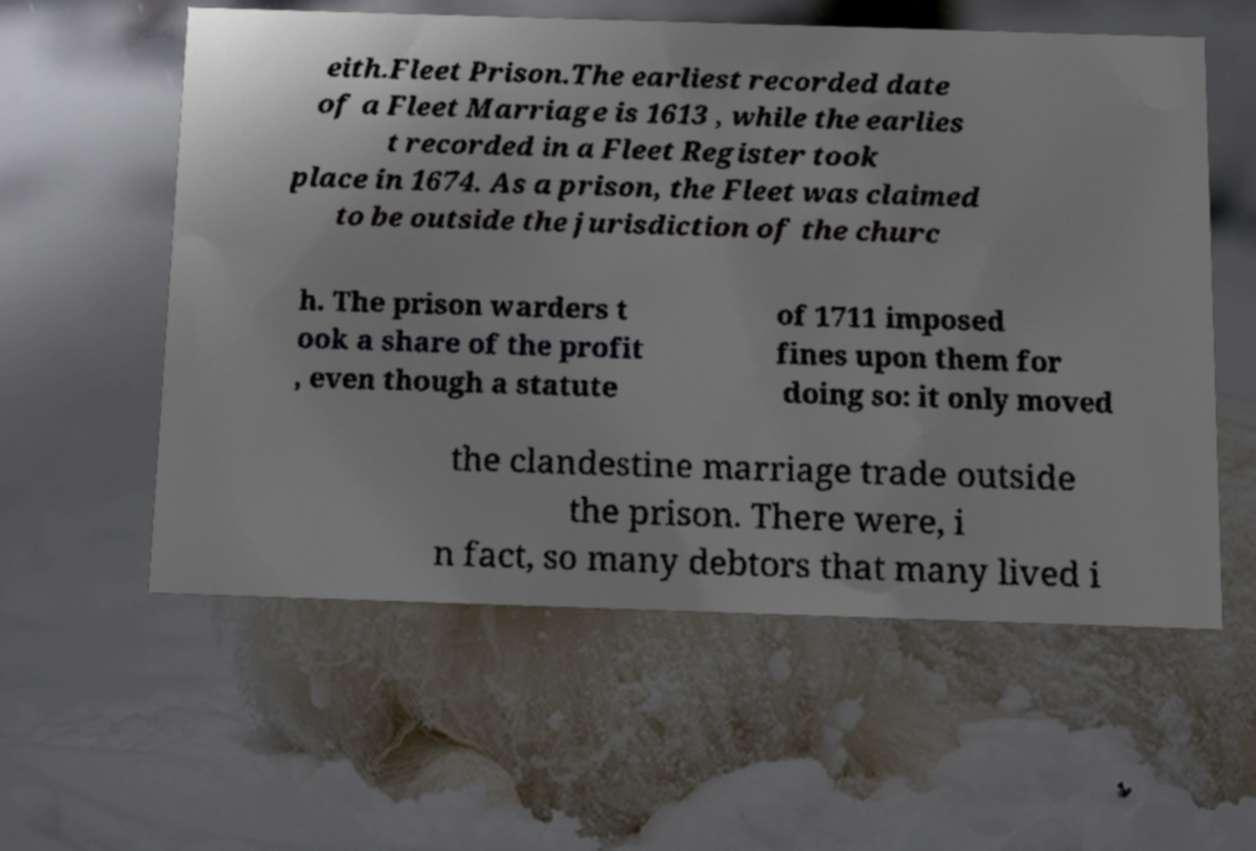Please read and relay the text visible in this image. What does it say? eith.Fleet Prison.The earliest recorded date of a Fleet Marriage is 1613 , while the earlies t recorded in a Fleet Register took place in 1674. As a prison, the Fleet was claimed to be outside the jurisdiction of the churc h. The prison warders t ook a share of the profit , even though a statute of 1711 imposed fines upon them for doing so: it only moved the clandestine marriage trade outside the prison. There were, i n fact, so many debtors that many lived i 